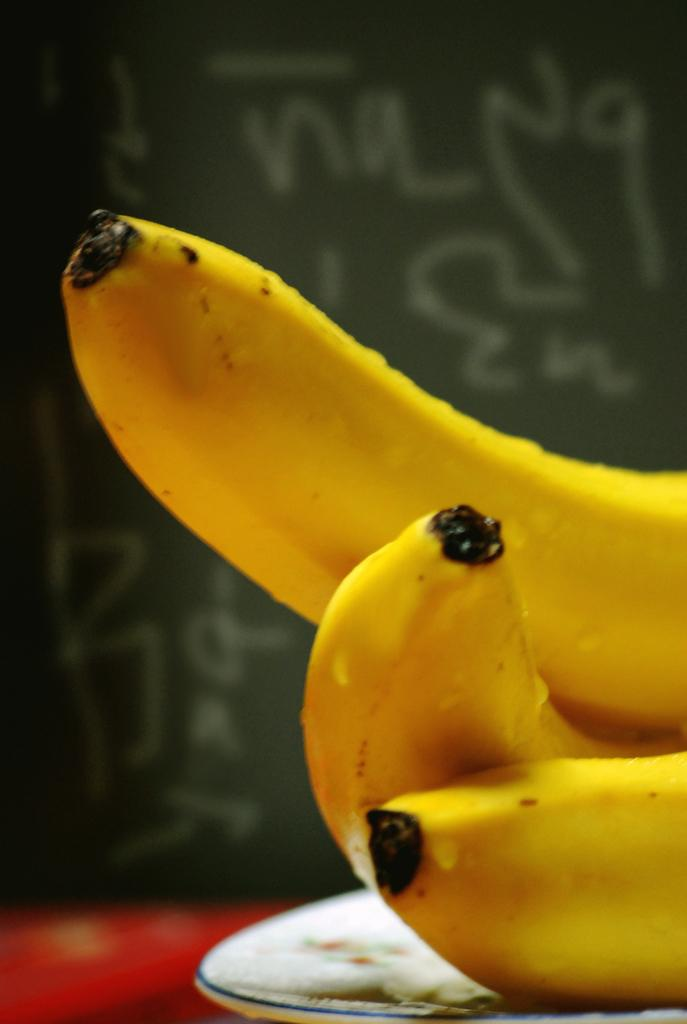What type of fruit is on the plate in the image? There are bananas on a plate in the image. Where is the plate located in the image? The plate is placed on a surface in the image. What can be seen in the background of the image? There is text visible in the background of the image. Can you see any vegetables growing in the lake in the image? There is no lake or vegetables present in the image; it features a plate of bananas and text in the background. 